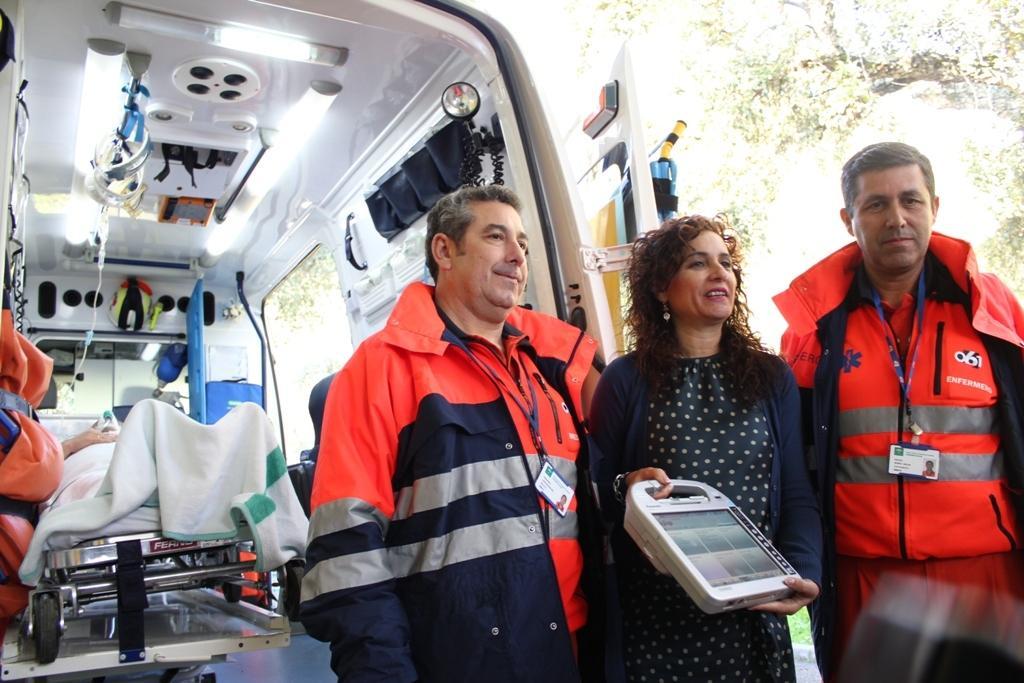Describe this image in one or two sentences. In this image on the left there is an ambulance. In the left three people are standing. In the middle a lady is holding something. In the background there are trees. Inside the ambulance a person is lying on the stretcher. 